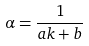Convert formula to latex. <formula><loc_0><loc_0><loc_500><loc_500>\alpha = { \frac { 1 } { a k + b } }</formula> 